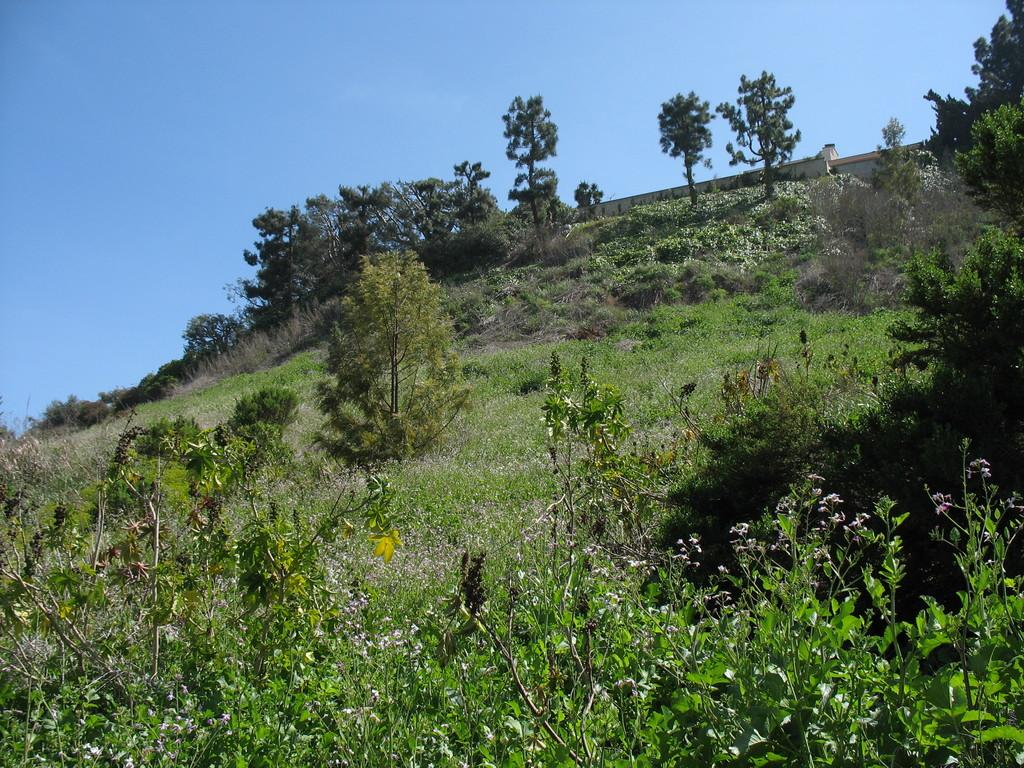What type of vegetation can be seen in the image? There are trees, plants, and grass visible in the image. What kind of terrain is depicted in the image? The image appears to depict a hill. What structure is present in the image? There is a wall in the image. What part of the natural environment is visible in the image? The sky is visible in the image. What type of silk is draped over the trees in the image? There is no silk present in the image; it features trees, plants, grass, a hill, a wall, and the sky. What brand of soda is being advertised on the wall in the image? There is no soda or advertisement present on the wall in the image; it is a plain wall. 